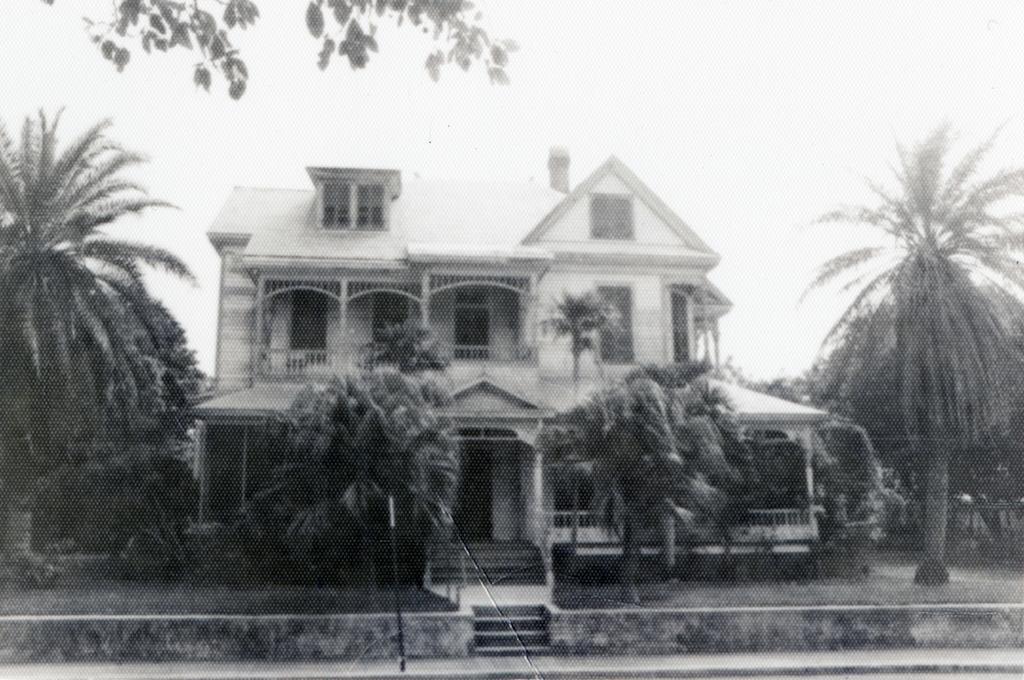Please provide a concise description of this image. It is the black and white image in which we can see there is a house in the middle. Around the house there are trees. In the middle there are steps. At the bottom there is a footpath on which there is a pole. 